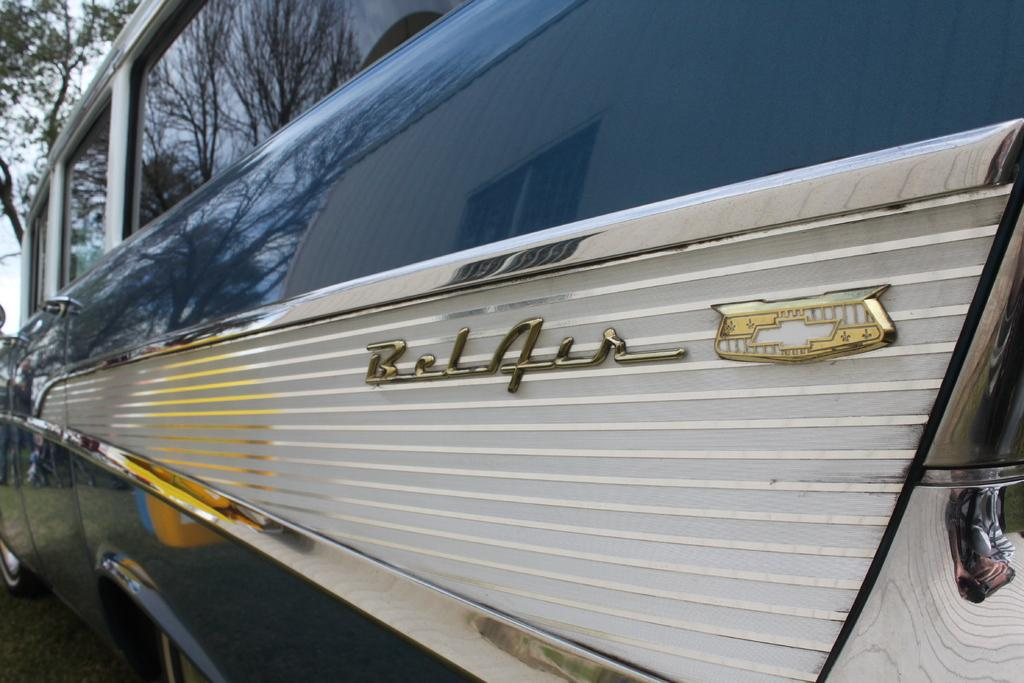What is the main subject in the image? There is a vehicle in the image. What can be seen on the vehicle? There are wordings on the vehicle. What is the setting of the image? There is a road in the image. What can be seen in the background of the image? There are trees in the background of the image. What is visible above the vehicle and road? There is a sky visible in the image. What type of authority is depicted in the image? There is no authority figure present in the image; it features a vehicle on a road with trees and sky in the background. What substance is being marked by the vehicle in the image? There is no substance being marked by the vehicle in the image; it only has wordings on it. 